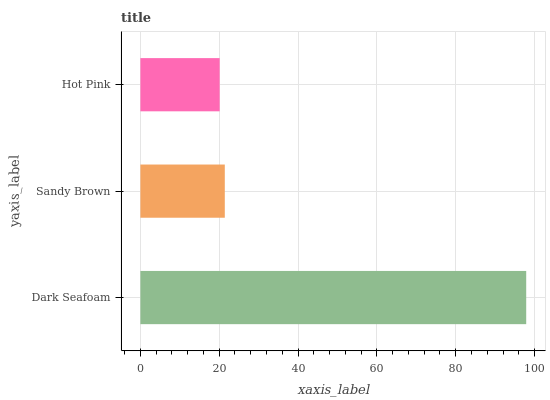Is Hot Pink the minimum?
Answer yes or no. Yes. Is Dark Seafoam the maximum?
Answer yes or no. Yes. Is Sandy Brown the minimum?
Answer yes or no. No. Is Sandy Brown the maximum?
Answer yes or no. No. Is Dark Seafoam greater than Sandy Brown?
Answer yes or no. Yes. Is Sandy Brown less than Dark Seafoam?
Answer yes or no. Yes. Is Sandy Brown greater than Dark Seafoam?
Answer yes or no. No. Is Dark Seafoam less than Sandy Brown?
Answer yes or no. No. Is Sandy Brown the high median?
Answer yes or no. Yes. Is Sandy Brown the low median?
Answer yes or no. Yes. Is Hot Pink the high median?
Answer yes or no. No. Is Dark Seafoam the low median?
Answer yes or no. No. 